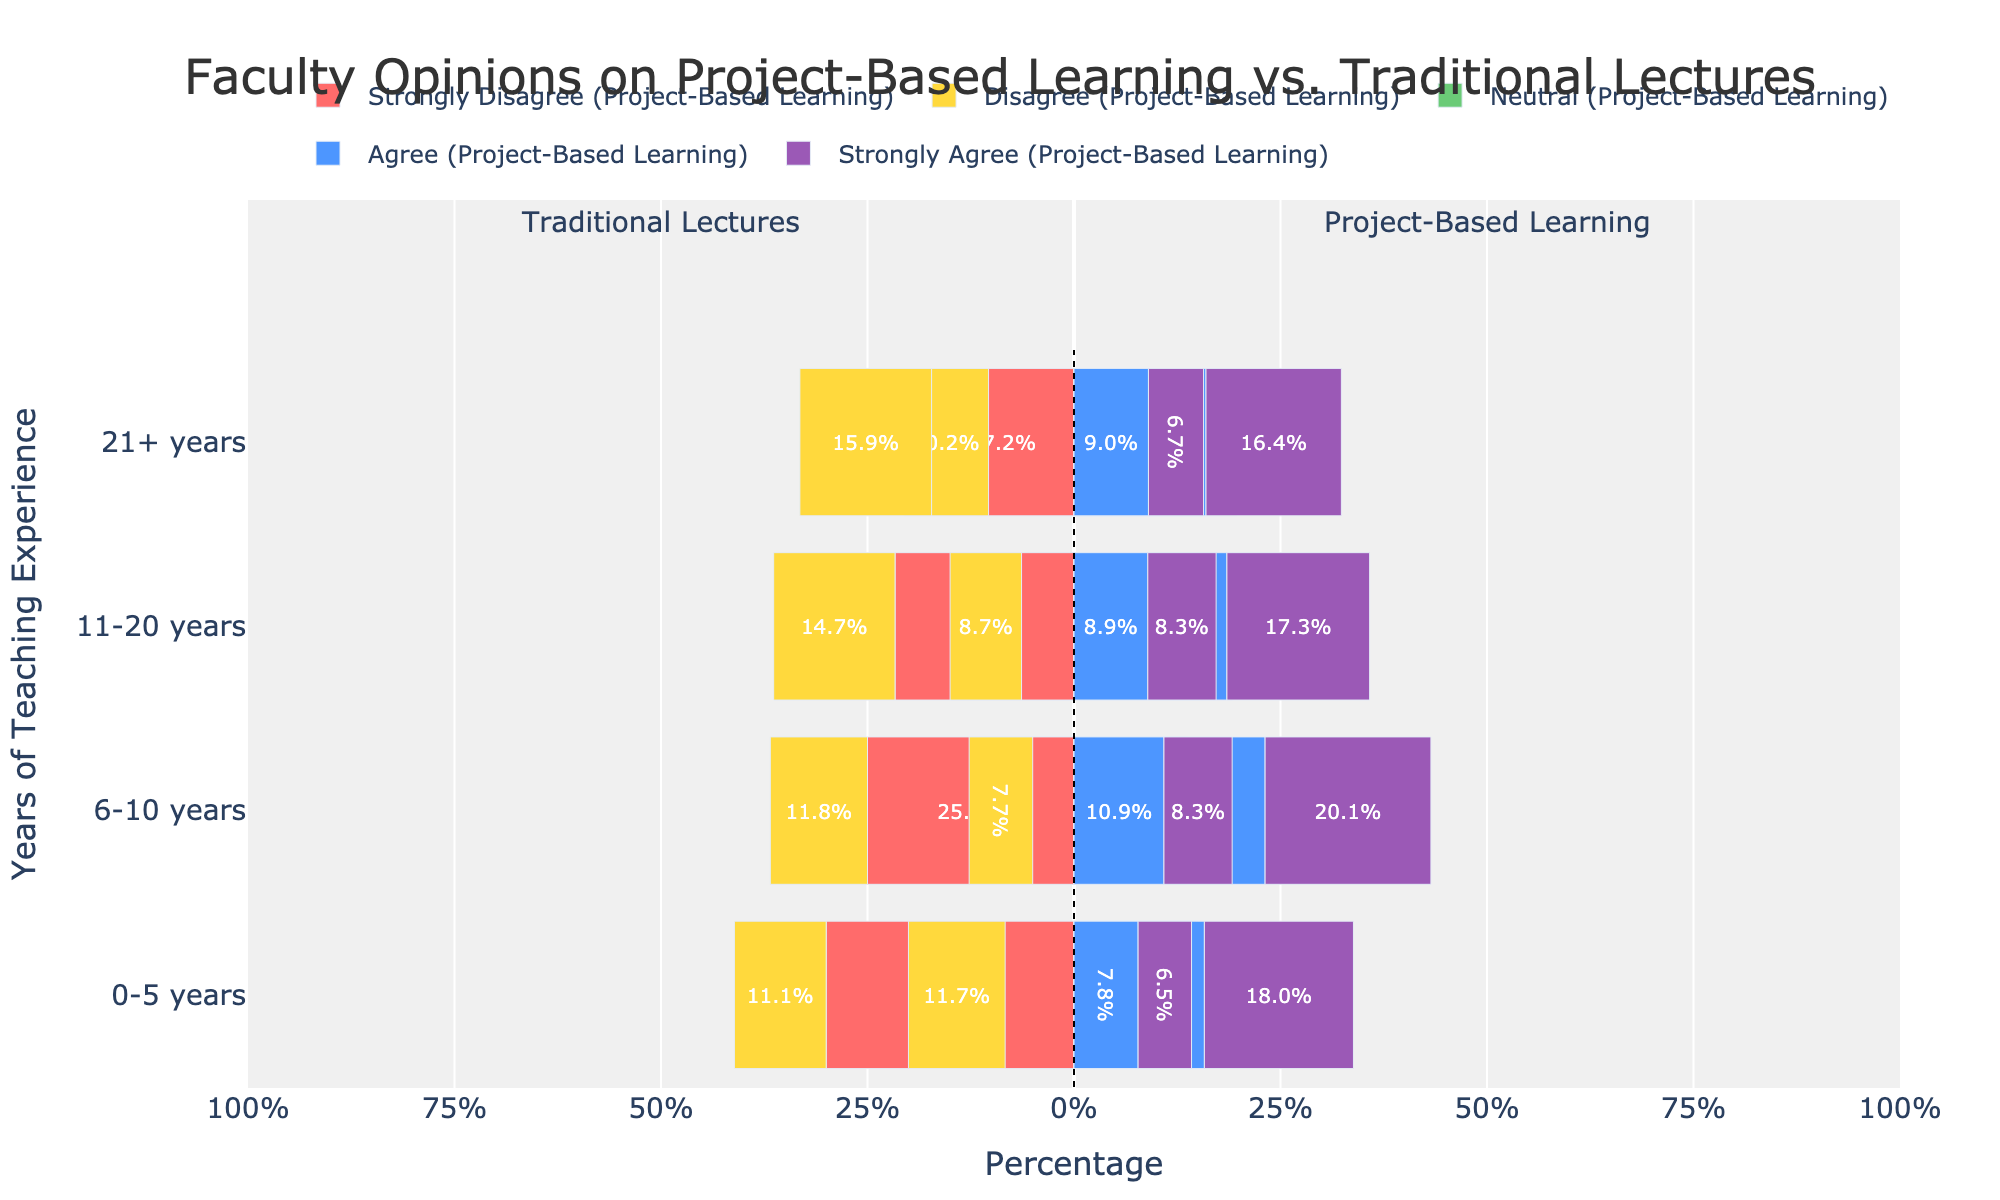Which type of learning had a higher percentage of agreement among faculty with 0-5 years of experience? By looking at the 0-5 years group for both types of learning, we see that the bars on the right (representing agreement) are longer for Project-Based Learning compared to Traditional Lectures. "Agree" and "Strongly Agree" combined for Project-Based Learning are longer than for Traditional Lectures.
Answer: Project-Based Learning How do faculty with 6-10 years of experience view Project-Based Learning compared to Traditional Lectures? Faculty with 6-10 years of experience show a higher percentage of positive responses (Agree and Strongly Agree) for Project-Based Learning than for Traditional Lectures. The bars representing agreement for Project-Based Learning are notably longer.
Answer: More positive for Project-Based Learning What's the difference in the percentage of faculty who agree with Project-Based Learning vs. those who agree with Traditional Lectures among those with 11-20 years of experience? For 11-20 years of experience, the "Agree" bar for Project-Based Learning is longer compared to Traditional Lectures. Specifically, Project-Based Learning has an "Agree" percentage represented by a larger bar segment compared to Traditional Lectures.
Answer: Higher for Project-Based Learning Which experience group has the highest percentage of strong disagreement for Traditional Lectures? Looking at the red bars (Strongly Disagree) across all experience groups for Traditional Lectures, the 0-5 years group has the longest bar.
Answer: 0-5 years What is the trend in the neutral responses for Project-Based Learning across different experience levels? The green bars (Neutral) for Project-Based Learning decrease in length as experience increases. The longest green bar is in the 0-5 years group, and the shortest is in the 21+ years group.
Answer: Decreasing trend For faculty with over 21 years of experience, which type of learning has more neutral responses? For the 21+ years group, the green bar (Neutral) is noticeably longer for Traditional Lectures compared to Project-Based Learning.
Answer: Traditional Lectures Compare the percentage of strong agreement for Traditional Lectures and Project-Based Learning among faculty with 6-10 years of experience. The purple bar (Strongly Agree) for faculty with 6-10 years of experience is longer for Project-Based Learning than for Traditional Lectures, indicating a higher percentage of strong agreement.
Answer: Project-Based Learning Which teaching experience group has the least disagreement towards Project-Based Learning? The red and orange bars (Strongly Disagree and Disagree) are shortest for the 6-10 years group, indicating the least disagreement levels among the experience groups for Project-Based Learning.
Answer: 6-10 years 